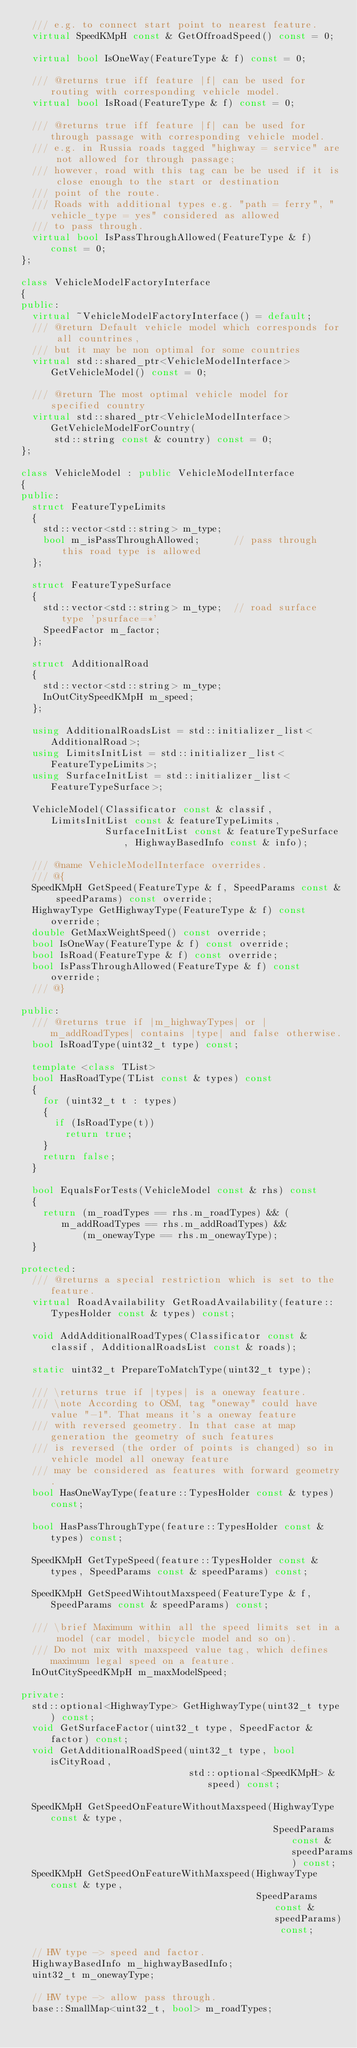Convert code to text. <code><loc_0><loc_0><loc_500><loc_500><_C++_>  /// e.g. to connect start point to nearest feature.
  virtual SpeedKMpH const & GetOffroadSpeed() const = 0;

  virtual bool IsOneWay(FeatureType & f) const = 0;

  /// @returns true iff feature |f| can be used for routing with corresponding vehicle model.
  virtual bool IsRoad(FeatureType & f) const = 0;

  /// @returns true iff feature |f| can be used for through passage with corresponding vehicle model.
  /// e.g. in Russia roads tagged "highway = service" are not allowed for through passage;
  /// however, road with this tag can be be used if it is close enough to the start or destination
  /// point of the route.
  /// Roads with additional types e.g. "path = ferry", "vehicle_type = yes" considered as allowed
  /// to pass through.
  virtual bool IsPassThroughAllowed(FeatureType & f) const = 0;
};

class VehicleModelFactoryInterface
{
public:
  virtual ~VehicleModelFactoryInterface() = default;
  /// @return Default vehicle model which corresponds for all countrines,
  /// but it may be non optimal for some countries
  virtual std::shared_ptr<VehicleModelInterface> GetVehicleModel() const = 0;

  /// @return The most optimal vehicle model for specified country
  virtual std::shared_ptr<VehicleModelInterface> GetVehicleModelForCountry(
      std::string const & country) const = 0;
};

class VehicleModel : public VehicleModelInterface
{
public:
  struct FeatureTypeLimits
  {
    std::vector<std::string> m_type;
    bool m_isPassThroughAllowed;      // pass through this road type is allowed
  };

  struct FeatureTypeSurface
  {
    std::vector<std::string> m_type;  // road surface type 'psurface=*'
    SpeedFactor m_factor;
  };

  struct AdditionalRoad
  {
    std::vector<std::string> m_type;
    InOutCitySpeedKMpH m_speed;
  };

  using AdditionalRoadsList = std::initializer_list<AdditionalRoad>;
  using LimitsInitList = std::initializer_list<FeatureTypeLimits>;
  using SurfaceInitList = std::initializer_list<FeatureTypeSurface>;

  VehicleModel(Classificator const & classif, LimitsInitList const & featureTypeLimits,
               SurfaceInitList const & featureTypeSurface, HighwayBasedInfo const & info);

  /// @name VehicleModelInterface overrides.
  /// @{
  SpeedKMpH GetSpeed(FeatureType & f, SpeedParams const & speedParams) const override;
  HighwayType GetHighwayType(FeatureType & f) const override;
  double GetMaxWeightSpeed() const override;
  bool IsOneWay(FeatureType & f) const override;
  bool IsRoad(FeatureType & f) const override;
  bool IsPassThroughAllowed(FeatureType & f) const override;
  /// @}

public:
  /// @returns true if |m_highwayTypes| or |m_addRoadTypes| contains |type| and false otherwise.
  bool IsRoadType(uint32_t type) const;

  template <class TList>
  bool HasRoadType(TList const & types) const
  {
    for (uint32_t t : types)
    {
      if (IsRoadType(t))
        return true;
    }
    return false;
  }

  bool EqualsForTests(VehicleModel const & rhs) const
  {
    return (m_roadTypes == rhs.m_roadTypes) && (m_addRoadTypes == rhs.m_addRoadTypes) &&
           (m_onewayType == rhs.m_onewayType);
  }

protected:
  /// @returns a special restriction which is set to the feature.
  virtual RoadAvailability GetRoadAvailability(feature::TypesHolder const & types) const;

  void AddAdditionalRoadTypes(Classificator const & classif, AdditionalRoadsList const & roads);

  static uint32_t PrepareToMatchType(uint32_t type);

  /// \returns true if |types| is a oneway feature.
  /// \note According to OSM, tag "oneway" could have value "-1". That means it's a oneway feature
  /// with reversed geometry. In that case at map generation the geometry of such features
  /// is reversed (the order of points is changed) so in vehicle model all oneway feature
  /// may be considered as features with forward geometry.
  bool HasOneWayType(feature::TypesHolder const & types) const;

  bool HasPassThroughType(feature::TypesHolder const & types) const;

  SpeedKMpH GetTypeSpeed(feature::TypesHolder const & types, SpeedParams const & speedParams) const;

  SpeedKMpH GetSpeedWihtoutMaxspeed(FeatureType & f, SpeedParams const & speedParams) const;

  /// \brief Maximum within all the speed limits set in a model (car model, bicycle model and so on).
  /// Do not mix with maxspeed value tag, which defines maximum legal speed on a feature.
  InOutCitySpeedKMpH m_maxModelSpeed;

private:
  std::optional<HighwayType> GetHighwayType(uint32_t type) const;
  void GetSurfaceFactor(uint32_t type, SpeedFactor & factor) const;
  void GetAdditionalRoadSpeed(uint32_t type, bool isCityRoad,
                              std::optional<SpeedKMpH> & speed) const;

  SpeedKMpH GetSpeedOnFeatureWithoutMaxspeed(HighwayType const & type,
                                             SpeedParams const & speedParams) const;
  SpeedKMpH GetSpeedOnFeatureWithMaxspeed(HighwayType const & type,
                                          SpeedParams const & speedParams) const;

  // HW type -> speed and factor.
  HighwayBasedInfo m_highwayBasedInfo;
  uint32_t m_onewayType;

  // HW type -> allow pass through.
  base::SmallMap<uint32_t, bool> m_roadTypes;</code> 